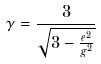<formula> <loc_0><loc_0><loc_500><loc_500>\gamma = \frac { 3 } { \sqrt { 3 - \frac { e ^ { 2 } } { g ^ { 2 } } } }</formula> 